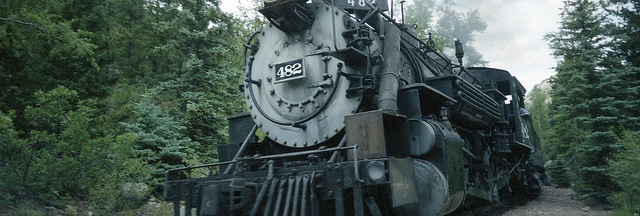Describe the objects in this image and their specific colors. I can see a train in darkgreen, black, gray, purple, and darkgray tones in this image. 